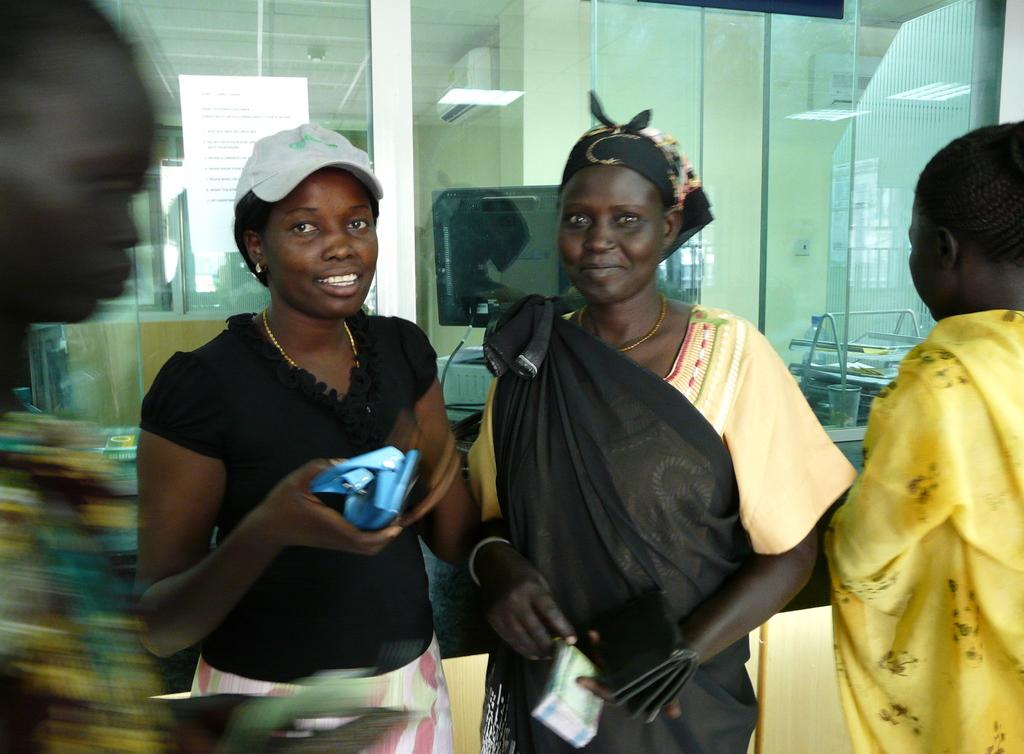Who or what is present in the image? There are people in the image. What are the people doing in the image? The people are holding objects in their hands. Can you describe any written material in the image? Yes, there is a paper with text visible in the image. How many clams can be seen in the image? There are no clams present in the image. What type of lizards are crawling on the paper with text? There are no lizards present in the image. 